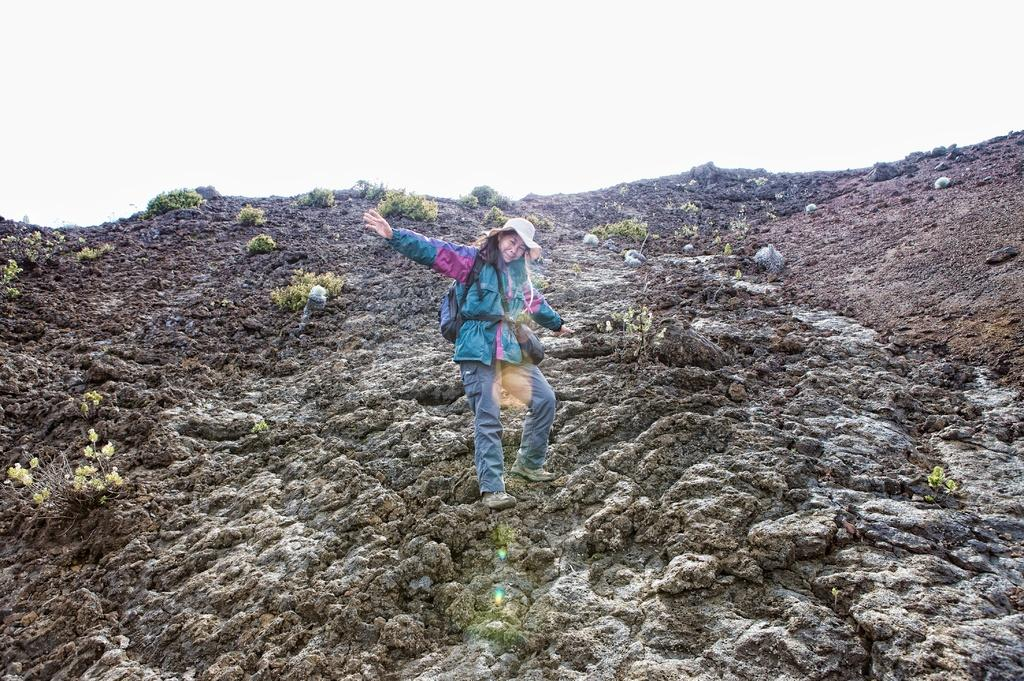Who is the main subject in the image? There is a woman in the center of the image. What is the woman wearing on her head? The woman is wearing a hat. What surface is the woman standing on? The woman is standing on the ground. What can be seen in the background of the image? There are plants in the background of the image. What is visible at the top of the image? The sky is visible at the top of the image. How does the woman's chin affect the temperature in the image? The woman's chin does not affect the temperature in the image, as there is no mention of heat or temperature in the provided facts. 